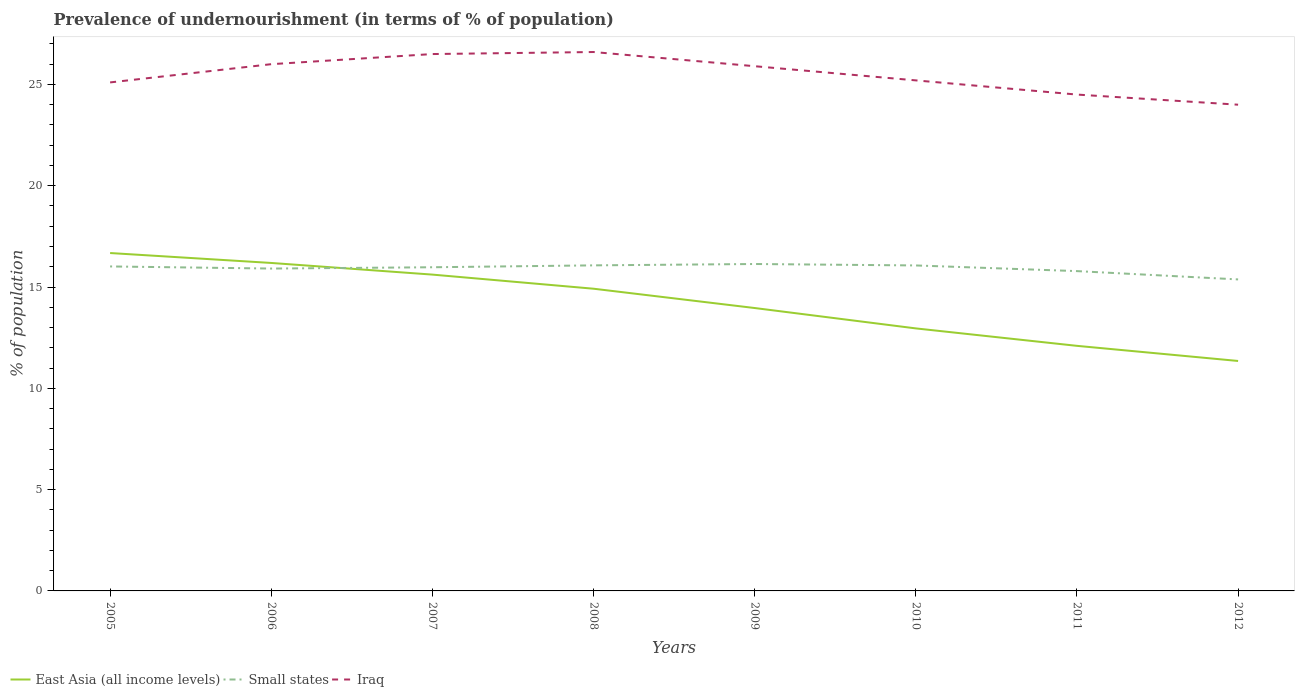How many different coloured lines are there?
Offer a very short reply. 3. Does the line corresponding to Iraq intersect with the line corresponding to Small states?
Offer a terse response. No. Is the number of lines equal to the number of legend labels?
Give a very brief answer. Yes. Across all years, what is the maximum percentage of undernourished population in Small states?
Your response must be concise. 15.38. In which year was the percentage of undernourished population in Iraq maximum?
Provide a succinct answer. 2012. What is the total percentage of undernourished population in East Asia (all income levels) in the graph?
Offer a terse response. 1.76. What is the difference between the highest and the second highest percentage of undernourished population in East Asia (all income levels)?
Your response must be concise. 5.33. How many lines are there?
Ensure brevity in your answer.  3. How many legend labels are there?
Give a very brief answer. 3. How are the legend labels stacked?
Provide a short and direct response. Horizontal. What is the title of the graph?
Give a very brief answer. Prevalence of undernourishment (in terms of % of population). What is the label or title of the X-axis?
Make the answer very short. Years. What is the label or title of the Y-axis?
Your answer should be compact. % of population. What is the % of population of East Asia (all income levels) in 2005?
Your answer should be compact. 16.68. What is the % of population of Small states in 2005?
Ensure brevity in your answer.  16.02. What is the % of population of Iraq in 2005?
Your answer should be compact. 25.1. What is the % of population in East Asia (all income levels) in 2006?
Your answer should be very brief. 16.19. What is the % of population of Small states in 2006?
Your answer should be very brief. 15.91. What is the % of population in Iraq in 2006?
Your answer should be compact. 26. What is the % of population of East Asia (all income levels) in 2007?
Ensure brevity in your answer.  15.61. What is the % of population of Small states in 2007?
Your answer should be very brief. 15.98. What is the % of population in East Asia (all income levels) in 2008?
Your answer should be very brief. 14.92. What is the % of population of Small states in 2008?
Your answer should be very brief. 16.07. What is the % of population in Iraq in 2008?
Keep it short and to the point. 26.6. What is the % of population in East Asia (all income levels) in 2009?
Ensure brevity in your answer.  13.96. What is the % of population in Small states in 2009?
Offer a terse response. 16.14. What is the % of population in Iraq in 2009?
Your response must be concise. 25.9. What is the % of population in East Asia (all income levels) in 2010?
Provide a succinct answer. 12.96. What is the % of population of Small states in 2010?
Keep it short and to the point. 16.07. What is the % of population in Iraq in 2010?
Your answer should be very brief. 25.2. What is the % of population in East Asia (all income levels) in 2011?
Your answer should be very brief. 12.1. What is the % of population in Small states in 2011?
Give a very brief answer. 15.79. What is the % of population in Iraq in 2011?
Give a very brief answer. 24.5. What is the % of population of East Asia (all income levels) in 2012?
Keep it short and to the point. 11.35. What is the % of population in Small states in 2012?
Provide a short and direct response. 15.38. Across all years, what is the maximum % of population of East Asia (all income levels)?
Offer a terse response. 16.68. Across all years, what is the maximum % of population in Small states?
Ensure brevity in your answer.  16.14. Across all years, what is the maximum % of population in Iraq?
Offer a very short reply. 26.6. Across all years, what is the minimum % of population of East Asia (all income levels)?
Provide a short and direct response. 11.35. Across all years, what is the minimum % of population in Small states?
Provide a short and direct response. 15.38. What is the total % of population of East Asia (all income levels) in the graph?
Keep it short and to the point. 113.77. What is the total % of population of Small states in the graph?
Offer a very short reply. 127.34. What is the total % of population of Iraq in the graph?
Provide a succinct answer. 203.8. What is the difference between the % of population of East Asia (all income levels) in 2005 and that in 2006?
Give a very brief answer. 0.49. What is the difference between the % of population of Small states in 2005 and that in 2006?
Provide a succinct answer. 0.1. What is the difference between the % of population in East Asia (all income levels) in 2005 and that in 2007?
Provide a succinct answer. 1.06. What is the difference between the % of population in Small states in 2005 and that in 2007?
Provide a succinct answer. 0.04. What is the difference between the % of population of East Asia (all income levels) in 2005 and that in 2008?
Ensure brevity in your answer.  1.76. What is the difference between the % of population of Small states in 2005 and that in 2008?
Keep it short and to the point. -0.05. What is the difference between the % of population in Iraq in 2005 and that in 2008?
Provide a short and direct response. -1.5. What is the difference between the % of population of East Asia (all income levels) in 2005 and that in 2009?
Ensure brevity in your answer.  2.71. What is the difference between the % of population in Small states in 2005 and that in 2009?
Your answer should be compact. -0.12. What is the difference between the % of population of Iraq in 2005 and that in 2009?
Make the answer very short. -0.8. What is the difference between the % of population in East Asia (all income levels) in 2005 and that in 2010?
Your answer should be compact. 3.72. What is the difference between the % of population in Small states in 2005 and that in 2010?
Ensure brevity in your answer.  -0.05. What is the difference between the % of population of East Asia (all income levels) in 2005 and that in 2011?
Offer a terse response. 4.58. What is the difference between the % of population in Small states in 2005 and that in 2011?
Offer a very short reply. 0.23. What is the difference between the % of population of Iraq in 2005 and that in 2011?
Provide a short and direct response. 0.6. What is the difference between the % of population of East Asia (all income levels) in 2005 and that in 2012?
Your answer should be very brief. 5.33. What is the difference between the % of population of Small states in 2005 and that in 2012?
Offer a terse response. 0.64. What is the difference between the % of population of Iraq in 2005 and that in 2012?
Your answer should be very brief. 1.1. What is the difference between the % of population in East Asia (all income levels) in 2006 and that in 2007?
Ensure brevity in your answer.  0.57. What is the difference between the % of population of Small states in 2006 and that in 2007?
Keep it short and to the point. -0.06. What is the difference between the % of population in East Asia (all income levels) in 2006 and that in 2008?
Provide a succinct answer. 1.27. What is the difference between the % of population of Small states in 2006 and that in 2008?
Offer a very short reply. -0.16. What is the difference between the % of population of Iraq in 2006 and that in 2008?
Offer a very short reply. -0.6. What is the difference between the % of population of East Asia (all income levels) in 2006 and that in 2009?
Your answer should be compact. 2.22. What is the difference between the % of population in Small states in 2006 and that in 2009?
Your answer should be very brief. -0.22. What is the difference between the % of population of East Asia (all income levels) in 2006 and that in 2010?
Ensure brevity in your answer.  3.23. What is the difference between the % of population of Small states in 2006 and that in 2010?
Your answer should be very brief. -0.15. What is the difference between the % of population in Iraq in 2006 and that in 2010?
Your response must be concise. 0.8. What is the difference between the % of population in East Asia (all income levels) in 2006 and that in 2011?
Give a very brief answer. 4.09. What is the difference between the % of population of Small states in 2006 and that in 2011?
Provide a short and direct response. 0.13. What is the difference between the % of population in Iraq in 2006 and that in 2011?
Give a very brief answer. 1.5. What is the difference between the % of population in East Asia (all income levels) in 2006 and that in 2012?
Provide a succinct answer. 4.84. What is the difference between the % of population of Small states in 2006 and that in 2012?
Your answer should be very brief. 0.54. What is the difference between the % of population in Iraq in 2006 and that in 2012?
Your answer should be very brief. 2. What is the difference between the % of population of East Asia (all income levels) in 2007 and that in 2008?
Give a very brief answer. 0.7. What is the difference between the % of population of Small states in 2007 and that in 2008?
Offer a terse response. -0.09. What is the difference between the % of population of East Asia (all income levels) in 2007 and that in 2009?
Your answer should be very brief. 1.65. What is the difference between the % of population in Small states in 2007 and that in 2009?
Keep it short and to the point. -0.16. What is the difference between the % of population of Iraq in 2007 and that in 2009?
Your response must be concise. 0.6. What is the difference between the % of population of East Asia (all income levels) in 2007 and that in 2010?
Provide a short and direct response. 2.66. What is the difference between the % of population of Small states in 2007 and that in 2010?
Offer a very short reply. -0.09. What is the difference between the % of population in Iraq in 2007 and that in 2010?
Provide a short and direct response. 1.3. What is the difference between the % of population in East Asia (all income levels) in 2007 and that in 2011?
Ensure brevity in your answer.  3.52. What is the difference between the % of population in Small states in 2007 and that in 2011?
Ensure brevity in your answer.  0.19. What is the difference between the % of population of East Asia (all income levels) in 2007 and that in 2012?
Make the answer very short. 4.26. What is the difference between the % of population in Small states in 2007 and that in 2012?
Provide a short and direct response. 0.6. What is the difference between the % of population in Iraq in 2007 and that in 2012?
Your answer should be compact. 2.5. What is the difference between the % of population in East Asia (all income levels) in 2008 and that in 2009?
Offer a very short reply. 0.95. What is the difference between the % of population in Small states in 2008 and that in 2009?
Offer a very short reply. -0.07. What is the difference between the % of population in Iraq in 2008 and that in 2009?
Give a very brief answer. 0.7. What is the difference between the % of population in East Asia (all income levels) in 2008 and that in 2010?
Keep it short and to the point. 1.96. What is the difference between the % of population in Small states in 2008 and that in 2010?
Provide a short and direct response. 0. What is the difference between the % of population in Iraq in 2008 and that in 2010?
Ensure brevity in your answer.  1.4. What is the difference between the % of population of East Asia (all income levels) in 2008 and that in 2011?
Make the answer very short. 2.82. What is the difference between the % of population of Small states in 2008 and that in 2011?
Provide a succinct answer. 0.28. What is the difference between the % of population in East Asia (all income levels) in 2008 and that in 2012?
Keep it short and to the point. 3.57. What is the difference between the % of population in Small states in 2008 and that in 2012?
Ensure brevity in your answer.  0.69. What is the difference between the % of population of East Asia (all income levels) in 2009 and that in 2010?
Offer a very short reply. 1.01. What is the difference between the % of population of Small states in 2009 and that in 2010?
Provide a short and direct response. 0.07. What is the difference between the % of population of East Asia (all income levels) in 2009 and that in 2011?
Your response must be concise. 1.87. What is the difference between the % of population of Small states in 2009 and that in 2011?
Your answer should be very brief. 0.35. What is the difference between the % of population of East Asia (all income levels) in 2009 and that in 2012?
Your response must be concise. 2.61. What is the difference between the % of population in Small states in 2009 and that in 2012?
Offer a very short reply. 0.76. What is the difference between the % of population in East Asia (all income levels) in 2010 and that in 2011?
Keep it short and to the point. 0.86. What is the difference between the % of population in Small states in 2010 and that in 2011?
Make the answer very short. 0.28. What is the difference between the % of population of East Asia (all income levels) in 2010 and that in 2012?
Make the answer very short. 1.61. What is the difference between the % of population in Small states in 2010 and that in 2012?
Offer a very short reply. 0.69. What is the difference between the % of population of East Asia (all income levels) in 2011 and that in 2012?
Offer a terse response. 0.75. What is the difference between the % of population in Small states in 2011 and that in 2012?
Keep it short and to the point. 0.41. What is the difference between the % of population of Iraq in 2011 and that in 2012?
Your response must be concise. 0.5. What is the difference between the % of population of East Asia (all income levels) in 2005 and the % of population of Small states in 2006?
Your response must be concise. 0.77. What is the difference between the % of population in East Asia (all income levels) in 2005 and the % of population in Iraq in 2006?
Make the answer very short. -9.32. What is the difference between the % of population of Small states in 2005 and the % of population of Iraq in 2006?
Give a very brief answer. -9.98. What is the difference between the % of population in East Asia (all income levels) in 2005 and the % of population in Small states in 2007?
Offer a terse response. 0.7. What is the difference between the % of population in East Asia (all income levels) in 2005 and the % of population in Iraq in 2007?
Ensure brevity in your answer.  -9.82. What is the difference between the % of population of Small states in 2005 and the % of population of Iraq in 2007?
Offer a very short reply. -10.48. What is the difference between the % of population in East Asia (all income levels) in 2005 and the % of population in Small states in 2008?
Provide a short and direct response. 0.61. What is the difference between the % of population of East Asia (all income levels) in 2005 and the % of population of Iraq in 2008?
Make the answer very short. -9.92. What is the difference between the % of population in Small states in 2005 and the % of population in Iraq in 2008?
Offer a very short reply. -10.58. What is the difference between the % of population of East Asia (all income levels) in 2005 and the % of population of Small states in 2009?
Provide a succinct answer. 0.54. What is the difference between the % of population in East Asia (all income levels) in 2005 and the % of population in Iraq in 2009?
Your answer should be very brief. -9.22. What is the difference between the % of population in Small states in 2005 and the % of population in Iraq in 2009?
Provide a succinct answer. -9.88. What is the difference between the % of population in East Asia (all income levels) in 2005 and the % of population in Small states in 2010?
Your response must be concise. 0.61. What is the difference between the % of population of East Asia (all income levels) in 2005 and the % of population of Iraq in 2010?
Provide a short and direct response. -8.52. What is the difference between the % of population in Small states in 2005 and the % of population in Iraq in 2010?
Keep it short and to the point. -9.18. What is the difference between the % of population in East Asia (all income levels) in 2005 and the % of population in Small states in 2011?
Give a very brief answer. 0.89. What is the difference between the % of population in East Asia (all income levels) in 2005 and the % of population in Iraq in 2011?
Offer a very short reply. -7.82. What is the difference between the % of population in Small states in 2005 and the % of population in Iraq in 2011?
Provide a short and direct response. -8.48. What is the difference between the % of population in East Asia (all income levels) in 2005 and the % of population in Small states in 2012?
Keep it short and to the point. 1.3. What is the difference between the % of population in East Asia (all income levels) in 2005 and the % of population in Iraq in 2012?
Ensure brevity in your answer.  -7.32. What is the difference between the % of population in Small states in 2005 and the % of population in Iraq in 2012?
Your response must be concise. -7.98. What is the difference between the % of population of East Asia (all income levels) in 2006 and the % of population of Small states in 2007?
Ensure brevity in your answer.  0.21. What is the difference between the % of population in East Asia (all income levels) in 2006 and the % of population in Iraq in 2007?
Your answer should be compact. -10.31. What is the difference between the % of population of Small states in 2006 and the % of population of Iraq in 2007?
Offer a terse response. -10.59. What is the difference between the % of population of East Asia (all income levels) in 2006 and the % of population of Small states in 2008?
Provide a short and direct response. 0.12. What is the difference between the % of population of East Asia (all income levels) in 2006 and the % of population of Iraq in 2008?
Your response must be concise. -10.41. What is the difference between the % of population in Small states in 2006 and the % of population in Iraq in 2008?
Provide a short and direct response. -10.69. What is the difference between the % of population of East Asia (all income levels) in 2006 and the % of population of Small states in 2009?
Provide a short and direct response. 0.05. What is the difference between the % of population of East Asia (all income levels) in 2006 and the % of population of Iraq in 2009?
Give a very brief answer. -9.71. What is the difference between the % of population in Small states in 2006 and the % of population in Iraq in 2009?
Offer a terse response. -9.99. What is the difference between the % of population of East Asia (all income levels) in 2006 and the % of population of Small states in 2010?
Your response must be concise. 0.12. What is the difference between the % of population of East Asia (all income levels) in 2006 and the % of population of Iraq in 2010?
Give a very brief answer. -9.01. What is the difference between the % of population of Small states in 2006 and the % of population of Iraq in 2010?
Keep it short and to the point. -9.29. What is the difference between the % of population in East Asia (all income levels) in 2006 and the % of population in Small states in 2011?
Give a very brief answer. 0.4. What is the difference between the % of population of East Asia (all income levels) in 2006 and the % of population of Iraq in 2011?
Your answer should be very brief. -8.31. What is the difference between the % of population of Small states in 2006 and the % of population of Iraq in 2011?
Ensure brevity in your answer.  -8.59. What is the difference between the % of population of East Asia (all income levels) in 2006 and the % of population of Small states in 2012?
Your answer should be very brief. 0.81. What is the difference between the % of population of East Asia (all income levels) in 2006 and the % of population of Iraq in 2012?
Keep it short and to the point. -7.81. What is the difference between the % of population in Small states in 2006 and the % of population in Iraq in 2012?
Your response must be concise. -8.09. What is the difference between the % of population in East Asia (all income levels) in 2007 and the % of population in Small states in 2008?
Your response must be concise. -0.46. What is the difference between the % of population in East Asia (all income levels) in 2007 and the % of population in Iraq in 2008?
Your answer should be compact. -10.99. What is the difference between the % of population in Small states in 2007 and the % of population in Iraq in 2008?
Your response must be concise. -10.62. What is the difference between the % of population of East Asia (all income levels) in 2007 and the % of population of Small states in 2009?
Your answer should be very brief. -0.52. What is the difference between the % of population of East Asia (all income levels) in 2007 and the % of population of Iraq in 2009?
Ensure brevity in your answer.  -10.29. What is the difference between the % of population of Small states in 2007 and the % of population of Iraq in 2009?
Your answer should be very brief. -9.92. What is the difference between the % of population of East Asia (all income levels) in 2007 and the % of population of Small states in 2010?
Your response must be concise. -0.45. What is the difference between the % of population in East Asia (all income levels) in 2007 and the % of population in Iraq in 2010?
Provide a short and direct response. -9.59. What is the difference between the % of population in Small states in 2007 and the % of population in Iraq in 2010?
Ensure brevity in your answer.  -9.22. What is the difference between the % of population in East Asia (all income levels) in 2007 and the % of population in Small states in 2011?
Give a very brief answer. -0.17. What is the difference between the % of population of East Asia (all income levels) in 2007 and the % of population of Iraq in 2011?
Provide a short and direct response. -8.89. What is the difference between the % of population in Small states in 2007 and the % of population in Iraq in 2011?
Offer a very short reply. -8.52. What is the difference between the % of population of East Asia (all income levels) in 2007 and the % of population of Small states in 2012?
Your answer should be very brief. 0.24. What is the difference between the % of population of East Asia (all income levels) in 2007 and the % of population of Iraq in 2012?
Your response must be concise. -8.39. What is the difference between the % of population in Small states in 2007 and the % of population in Iraq in 2012?
Provide a succinct answer. -8.02. What is the difference between the % of population of East Asia (all income levels) in 2008 and the % of population of Small states in 2009?
Offer a very short reply. -1.22. What is the difference between the % of population of East Asia (all income levels) in 2008 and the % of population of Iraq in 2009?
Offer a very short reply. -10.98. What is the difference between the % of population in Small states in 2008 and the % of population in Iraq in 2009?
Your response must be concise. -9.83. What is the difference between the % of population of East Asia (all income levels) in 2008 and the % of population of Small states in 2010?
Keep it short and to the point. -1.15. What is the difference between the % of population of East Asia (all income levels) in 2008 and the % of population of Iraq in 2010?
Your answer should be compact. -10.28. What is the difference between the % of population in Small states in 2008 and the % of population in Iraq in 2010?
Your answer should be very brief. -9.13. What is the difference between the % of population of East Asia (all income levels) in 2008 and the % of population of Small states in 2011?
Provide a succinct answer. -0.87. What is the difference between the % of population of East Asia (all income levels) in 2008 and the % of population of Iraq in 2011?
Make the answer very short. -9.58. What is the difference between the % of population in Small states in 2008 and the % of population in Iraq in 2011?
Provide a short and direct response. -8.43. What is the difference between the % of population in East Asia (all income levels) in 2008 and the % of population in Small states in 2012?
Provide a succinct answer. -0.46. What is the difference between the % of population in East Asia (all income levels) in 2008 and the % of population in Iraq in 2012?
Provide a succinct answer. -9.08. What is the difference between the % of population of Small states in 2008 and the % of population of Iraq in 2012?
Give a very brief answer. -7.93. What is the difference between the % of population in East Asia (all income levels) in 2009 and the % of population in Small states in 2010?
Provide a succinct answer. -2.1. What is the difference between the % of population in East Asia (all income levels) in 2009 and the % of population in Iraq in 2010?
Offer a terse response. -11.24. What is the difference between the % of population in Small states in 2009 and the % of population in Iraq in 2010?
Provide a short and direct response. -9.06. What is the difference between the % of population of East Asia (all income levels) in 2009 and the % of population of Small states in 2011?
Make the answer very short. -1.82. What is the difference between the % of population in East Asia (all income levels) in 2009 and the % of population in Iraq in 2011?
Your response must be concise. -10.54. What is the difference between the % of population in Small states in 2009 and the % of population in Iraq in 2011?
Offer a terse response. -8.36. What is the difference between the % of population of East Asia (all income levels) in 2009 and the % of population of Small states in 2012?
Give a very brief answer. -1.41. What is the difference between the % of population of East Asia (all income levels) in 2009 and the % of population of Iraq in 2012?
Provide a succinct answer. -10.04. What is the difference between the % of population of Small states in 2009 and the % of population of Iraq in 2012?
Make the answer very short. -7.86. What is the difference between the % of population of East Asia (all income levels) in 2010 and the % of population of Small states in 2011?
Offer a very short reply. -2.83. What is the difference between the % of population in East Asia (all income levels) in 2010 and the % of population in Iraq in 2011?
Your answer should be compact. -11.54. What is the difference between the % of population of Small states in 2010 and the % of population of Iraq in 2011?
Provide a short and direct response. -8.43. What is the difference between the % of population in East Asia (all income levels) in 2010 and the % of population in Small states in 2012?
Your response must be concise. -2.42. What is the difference between the % of population of East Asia (all income levels) in 2010 and the % of population of Iraq in 2012?
Ensure brevity in your answer.  -11.04. What is the difference between the % of population in Small states in 2010 and the % of population in Iraq in 2012?
Offer a terse response. -7.93. What is the difference between the % of population in East Asia (all income levels) in 2011 and the % of population in Small states in 2012?
Make the answer very short. -3.28. What is the difference between the % of population in East Asia (all income levels) in 2011 and the % of population in Iraq in 2012?
Offer a very short reply. -11.9. What is the difference between the % of population in Small states in 2011 and the % of population in Iraq in 2012?
Your answer should be very brief. -8.21. What is the average % of population in East Asia (all income levels) per year?
Your response must be concise. 14.22. What is the average % of population of Small states per year?
Offer a very short reply. 15.92. What is the average % of population in Iraq per year?
Offer a terse response. 25.48. In the year 2005, what is the difference between the % of population of East Asia (all income levels) and % of population of Small states?
Offer a very short reply. 0.66. In the year 2005, what is the difference between the % of population in East Asia (all income levels) and % of population in Iraq?
Your answer should be compact. -8.42. In the year 2005, what is the difference between the % of population of Small states and % of population of Iraq?
Give a very brief answer. -9.08. In the year 2006, what is the difference between the % of population of East Asia (all income levels) and % of population of Small states?
Give a very brief answer. 0.28. In the year 2006, what is the difference between the % of population in East Asia (all income levels) and % of population in Iraq?
Offer a terse response. -9.81. In the year 2006, what is the difference between the % of population of Small states and % of population of Iraq?
Make the answer very short. -10.09. In the year 2007, what is the difference between the % of population in East Asia (all income levels) and % of population in Small states?
Provide a short and direct response. -0.36. In the year 2007, what is the difference between the % of population in East Asia (all income levels) and % of population in Iraq?
Make the answer very short. -10.89. In the year 2007, what is the difference between the % of population of Small states and % of population of Iraq?
Give a very brief answer. -10.52. In the year 2008, what is the difference between the % of population in East Asia (all income levels) and % of population in Small states?
Offer a terse response. -1.15. In the year 2008, what is the difference between the % of population of East Asia (all income levels) and % of population of Iraq?
Provide a succinct answer. -11.68. In the year 2008, what is the difference between the % of population in Small states and % of population in Iraq?
Your answer should be compact. -10.53. In the year 2009, what is the difference between the % of population in East Asia (all income levels) and % of population in Small states?
Provide a short and direct response. -2.17. In the year 2009, what is the difference between the % of population of East Asia (all income levels) and % of population of Iraq?
Provide a succinct answer. -11.94. In the year 2009, what is the difference between the % of population of Small states and % of population of Iraq?
Ensure brevity in your answer.  -9.76. In the year 2010, what is the difference between the % of population of East Asia (all income levels) and % of population of Small states?
Provide a succinct answer. -3.11. In the year 2010, what is the difference between the % of population of East Asia (all income levels) and % of population of Iraq?
Give a very brief answer. -12.24. In the year 2010, what is the difference between the % of population in Small states and % of population in Iraq?
Keep it short and to the point. -9.13. In the year 2011, what is the difference between the % of population of East Asia (all income levels) and % of population of Small states?
Keep it short and to the point. -3.69. In the year 2011, what is the difference between the % of population in East Asia (all income levels) and % of population in Iraq?
Offer a terse response. -12.4. In the year 2011, what is the difference between the % of population of Small states and % of population of Iraq?
Keep it short and to the point. -8.71. In the year 2012, what is the difference between the % of population of East Asia (all income levels) and % of population of Small states?
Provide a succinct answer. -4.03. In the year 2012, what is the difference between the % of population in East Asia (all income levels) and % of population in Iraq?
Keep it short and to the point. -12.65. In the year 2012, what is the difference between the % of population in Small states and % of population in Iraq?
Keep it short and to the point. -8.62. What is the ratio of the % of population in East Asia (all income levels) in 2005 to that in 2006?
Your answer should be very brief. 1.03. What is the ratio of the % of population of Small states in 2005 to that in 2006?
Your response must be concise. 1.01. What is the ratio of the % of population in Iraq in 2005 to that in 2006?
Your answer should be very brief. 0.97. What is the ratio of the % of population in East Asia (all income levels) in 2005 to that in 2007?
Your answer should be compact. 1.07. What is the ratio of the % of population of Iraq in 2005 to that in 2007?
Offer a very short reply. 0.95. What is the ratio of the % of population of East Asia (all income levels) in 2005 to that in 2008?
Offer a terse response. 1.12. What is the ratio of the % of population of Iraq in 2005 to that in 2008?
Keep it short and to the point. 0.94. What is the ratio of the % of population in East Asia (all income levels) in 2005 to that in 2009?
Your response must be concise. 1.19. What is the ratio of the % of population in Small states in 2005 to that in 2009?
Your response must be concise. 0.99. What is the ratio of the % of population in Iraq in 2005 to that in 2009?
Offer a very short reply. 0.97. What is the ratio of the % of population in East Asia (all income levels) in 2005 to that in 2010?
Provide a succinct answer. 1.29. What is the ratio of the % of population in Small states in 2005 to that in 2010?
Make the answer very short. 1. What is the ratio of the % of population in Iraq in 2005 to that in 2010?
Provide a short and direct response. 1. What is the ratio of the % of population of East Asia (all income levels) in 2005 to that in 2011?
Offer a very short reply. 1.38. What is the ratio of the % of population of Small states in 2005 to that in 2011?
Make the answer very short. 1.01. What is the ratio of the % of population in Iraq in 2005 to that in 2011?
Your answer should be compact. 1.02. What is the ratio of the % of population of East Asia (all income levels) in 2005 to that in 2012?
Provide a succinct answer. 1.47. What is the ratio of the % of population of Small states in 2005 to that in 2012?
Give a very brief answer. 1.04. What is the ratio of the % of population of Iraq in 2005 to that in 2012?
Provide a short and direct response. 1.05. What is the ratio of the % of population in East Asia (all income levels) in 2006 to that in 2007?
Make the answer very short. 1.04. What is the ratio of the % of population in Iraq in 2006 to that in 2007?
Ensure brevity in your answer.  0.98. What is the ratio of the % of population of East Asia (all income levels) in 2006 to that in 2008?
Provide a succinct answer. 1.09. What is the ratio of the % of population of Small states in 2006 to that in 2008?
Provide a succinct answer. 0.99. What is the ratio of the % of population in Iraq in 2006 to that in 2008?
Make the answer very short. 0.98. What is the ratio of the % of population of East Asia (all income levels) in 2006 to that in 2009?
Offer a very short reply. 1.16. What is the ratio of the % of population of Small states in 2006 to that in 2009?
Make the answer very short. 0.99. What is the ratio of the % of population of East Asia (all income levels) in 2006 to that in 2010?
Ensure brevity in your answer.  1.25. What is the ratio of the % of population of Small states in 2006 to that in 2010?
Keep it short and to the point. 0.99. What is the ratio of the % of population in Iraq in 2006 to that in 2010?
Offer a terse response. 1.03. What is the ratio of the % of population of East Asia (all income levels) in 2006 to that in 2011?
Your response must be concise. 1.34. What is the ratio of the % of population of Small states in 2006 to that in 2011?
Make the answer very short. 1.01. What is the ratio of the % of population of Iraq in 2006 to that in 2011?
Offer a very short reply. 1.06. What is the ratio of the % of population of East Asia (all income levels) in 2006 to that in 2012?
Keep it short and to the point. 1.43. What is the ratio of the % of population of Small states in 2006 to that in 2012?
Your answer should be compact. 1.03. What is the ratio of the % of population of East Asia (all income levels) in 2007 to that in 2008?
Give a very brief answer. 1.05. What is the ratio of the % of population of Iraq in 2007 to that in 2008?
Offer a terse response. 1. What is the ratio of the % of population of East Asia (all income levels) in 2007 to that in 2009?
Provide a short and direct response. 1.12. What is the ratio of the % of population in Iraq in 2007 to that in 2009?
Give a very brief answer. 1.02. What is the ratio of the % of population in East Asia (all income levels) in 2007 to that in 2010?
Your answer should be very brief. 1.2. What is the ratio of the % of population of Iraq in 2007 to that in 2010?
Your answer should be compact. 1.05. What is the ratio of the % of population in East Asia (all income levels) in 2007 to that in 2011?
Your response must be concise. 1.29. What is the ratio of the % of population of Small states in 2007 to that in 2011?
Keep it short and to the point. 1.01. What is the ratio of the % of population of Iraq in 2007 to that in 2011?
Ensure brevity in your answer.  1.08. What is the ratio of the % of population of East Asia (all income levels) in 2007 to that in 2012?
Make the answer very short. 1.38. What is the ratio of the % of population in Small states in 2007 to that in 2012?
Provide a short and direct response. 1.04. What is the ratio of the % of population in Iraq in 2007 to that in 2012?
Give a very brief answer. 1.1. What is the ratio of the % of population in East Asia (all income levels) in 2008 to that in 2009?
Your response must be concise. 1.07. What is the ratio of the % of population in Iraq in 2008 to that in 2009?
Your response must be concise. 1.03. What is the ratio of the % of population in East Asia (all income levels) in 2008 to that in 2010?
Provide a short and direct response. 1.15. What is the ratio of the % of population of Iraq in 2008 to that in 2010?
Keep it short and to the point. 1.06. What is the ratio of the % of population in East Asia (all income levels) in 2008 to that in 2011?
Make the answer very short. 1.23. What is the ratio of the % of population in Iraq in 2008 to that in 2011?
Ensure brevity in your answer.  1.09. What is the ratio of the % of population of East Asia (all income levels) in 2008 to that in 2012?
Your answer should be compact. 1.31. What is the ratio of the % of population in Small states in 2008 to that in 2012?
Give a very brief answer. 1.05. What is the ratio of the % of population of Iraq in 2008 to that in 2012?
Keep it short and to the point. 1.11. What is the ratio of the % of population in East Asia (all income levels) in 2009 to that in 2010?
Ensure brevity in your answer.  1.08. What is the ratio of the % of population of Small states in 2009 to that in 2010?
Your answer should be very brief. 1. What is the ratio of the % of population in Iraq in 2009 to that in 2010?
Your answer should be compact. 1.03. What is the ratio of the % of population in East Asia (all income levels) in 2009 to that in 2011?
Your answer should be very brief. 1.15. What is the ratio of the % of population of Small states in 2009 to that in 2011?
Your answer should be very brief. 1.02. What is the ratio of the % of population of Iraq in 2009 to that in 2011?
Ensure brevity in your answer.  1.06. What is the ratio of the % of population of East Asia (all income levels) in 2009 to that in 2012?
Provide a short and direct response. 1.23. What is the ratio of the % of population of Small states in 2009 to that in 2012?
Provide a succinct answer. 1.05. What is the ratio of the % of population in Iraq in 2009 to that in 2012?
Keep it short and to the point. 1.08. What is the ratio of the % of population in East Asia (all income levels) in 2010 to that in 2011?
Provide a short and direct response. 1.07. What is the ratio of the % of population in Small states in 2010 to that in 2011?
Provide a short and direct response. 1.02. What is the ratio of the % of population of Iraq in 2010 to that in 2011?
Offer a very short reply. 1.03. What is the ratio of the % of population of East Asia (all income levels) in 2010 to that in 2012?
Provide a short and direct response. 1.14. What is the ratio of the % of population of Small states in 2010 to that in 2012?
Give a very brief answer. 1.04. What is the ratio of the % of population in Iraq in 2010 to that in 2012?
Ensure brevity in your answer.  1.05. What is the ratio of the % of population of East Asia (all income levels) in 2011 to that in 2012?
Provide a short and direct response. 1.07. What is the ratio of the % of population of Small states in 2011 to that in 2012?
Provide a short and direct response. 1.03. What is the ratio of the % of population in Iraq in 2011 to that in 2012?
Your answer should be very brief. 1.02. What is the difference between the highest and the second highest % of population of East Asia (all income levels)?
Your response must be concise. 0.49. What is the difference between the highest and the second highest % of population of Small states?
Offer a very short reply. 0.07. What is the difference between the highest and the second highest % of population in Iraq?
Provide a succinct answer. 0.1. What is the difference between the highest and the lowest % of population of East Asia (all income levels)?
Provide a succinct answer. 5.33. What is the difference between the highest and the lowest % of population of Small states?
Provide a succinct answer. 0.76. 